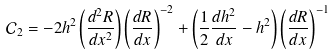Convert formula to latex. <formula><loc_0><loc_0><loc_500><loc_500>\mathcal { C } _ { 2 } = - 2 h ^ { 2 } \left ( \frac { d ^ { 2 } R } { d x ^ { 2 } } \right ) \left ( \frac { d R } { d x } \right ) ^ { - 2 } + \left ( \frac { 1 } { 2 } \frac { d h ^ { 2 } } { d x } - h ^ { 2 } \right ) \left ( \frac { d R } { d x } \right ) ^ { - 1 }</formula> 